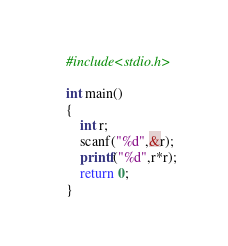Convert code to text. <code><loc_0><loc_0><loc_500><loc_500><_Awk_>#include<stdio.h>

int main()
{
    int r;
    scanf("%d",&r);
    printf("%d",r*r);
    return 0;
}
</code> 